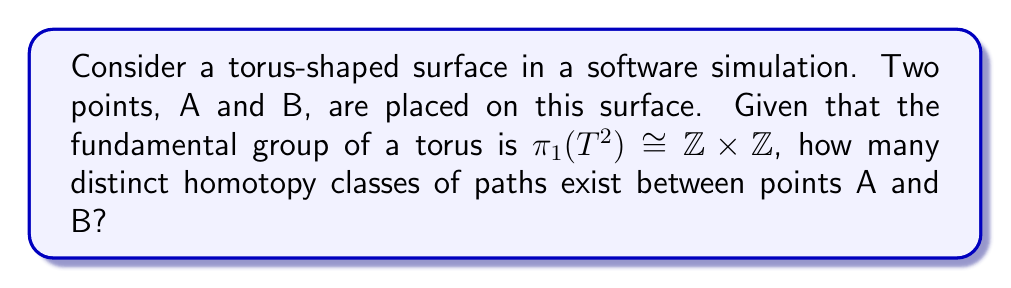Give your solution to this math problem. To solve this problem, we'll follow these steps:

1) First, recall that the fundamental group of a torus is isomorphic to $\mathbb{Z} \times \mathbb{Z}$. This means that any path on the torus can be characterized by two integers $(m,n)$, where $m$ represents the number of times the path winds around the torus in one direction, and $n$ represents the number of times it winds in the other direction.

2) In topology, two paths between the same points are homotopic if one can be continuously deformed into the other without leaving the surface. On a torus, paths between two fixed points A and B are homotopic if and only if they have the same winding numbers in both directions.

3) The key insight is that once we fix the endpoints A and B, the difference in winding numbers between any two paths connecting A and B is fixed. Let's call this difference $(a,b)$.

4) Now, any path from A to B can be represented as $(m,n)$, where $m$ and $n$ are integers. Another path $(m',n')$ will be in the same homotopy class if and only if:

   $m' = m + ka$
   $n' = n + kb$

   for some integer $k$.

5) This means that each homotopy class can be uniquely identified by the remainder when $m$ is divided by $a$ and when $n$ is divided by $b$.

6) The number of possible remainders when dividing by $a$ is $|a|$, and the number of possible remainders when dividing by $b$ is $|b|$.

7) Therefore, the total number of distinct homotopy classes is $|a| \times |b|$.

In the context of software engineering, this result could be crucial for optimizing pathfinding algorithms on toroidal data structures or in simulations involving torus-like surfaces.
Answer: $|a| \times |b|$ 